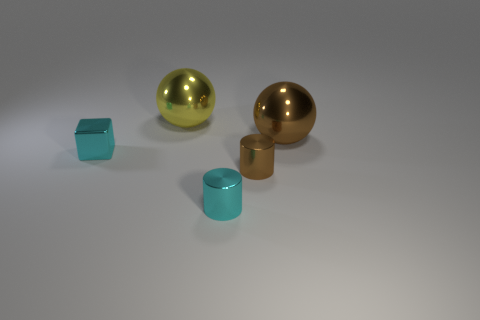Add 4 small brown rubber blocks. How many objects exist? 9 Subtract all blocks. How many objects are left? 4 Subtract 1 balls. How many balls are left? 1 Subtract all gray cylinders. Subtract all brown blocks. How many cylinders are left? 2 Subtract all large yellow spheres. Subtract all big brown balls. How many objects are left? 3 Add 4 small brown cylinders. How many small brown cylinders are left? 5 Add 5 cylinders. How many cylinders exist? 7 Subtract all yellow balls. How many balls are left? 1 Subtract 0 gray cylinders. How many objects are left? 5 